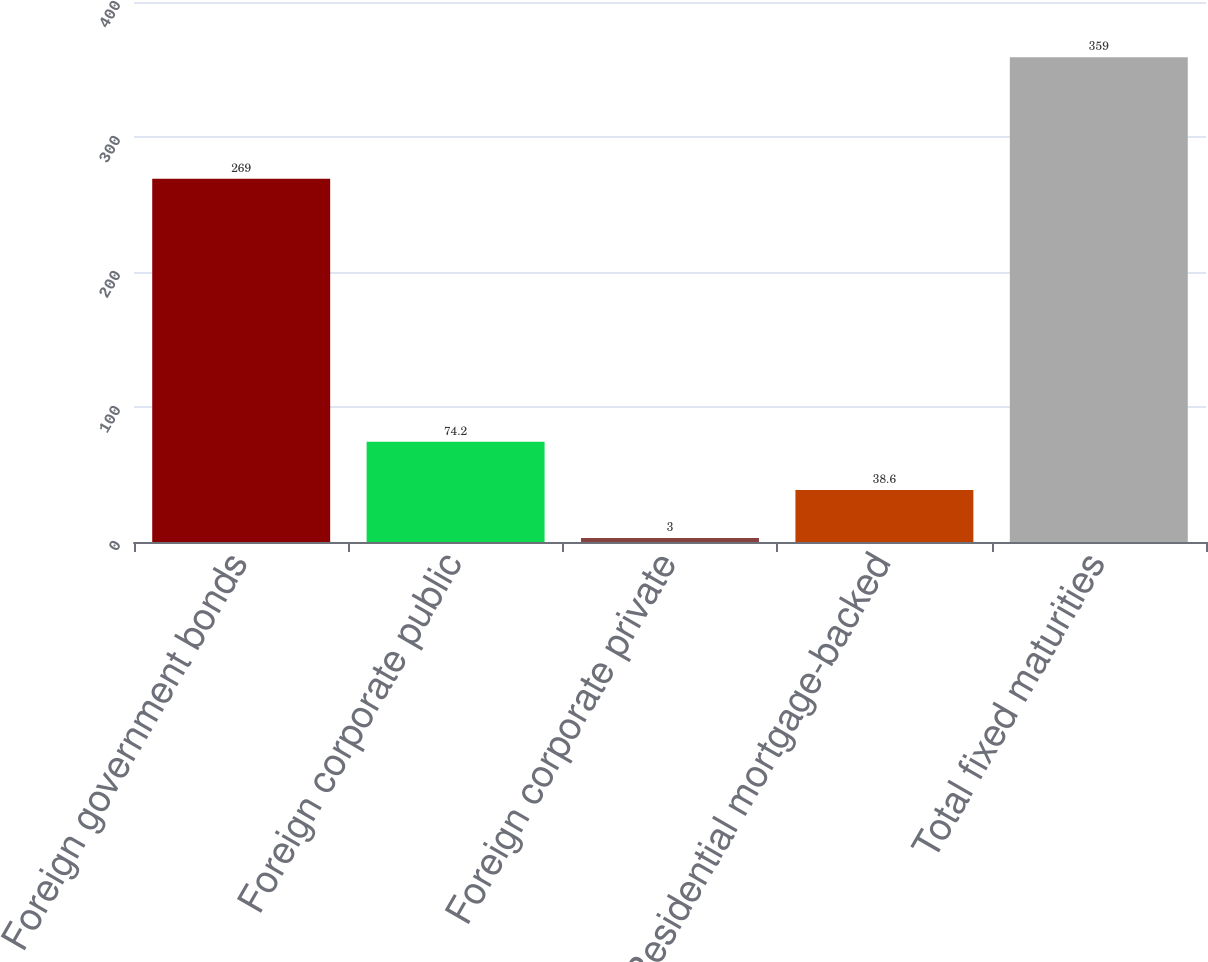Convert chart to OTSL. <chart><loc_0><loc_0><loc_500><loc_500><bar_chart><fcel>Foreign government bonds<fcel>Foreign corporate public<fcel>Foreign corporate private<fcel>Residential mortgage-backed<fcel>Total fixed maturities<nl><fcel>269<fcel>74.2<fcel>3<fcel>38.6<fcel>359<nl></chart> 